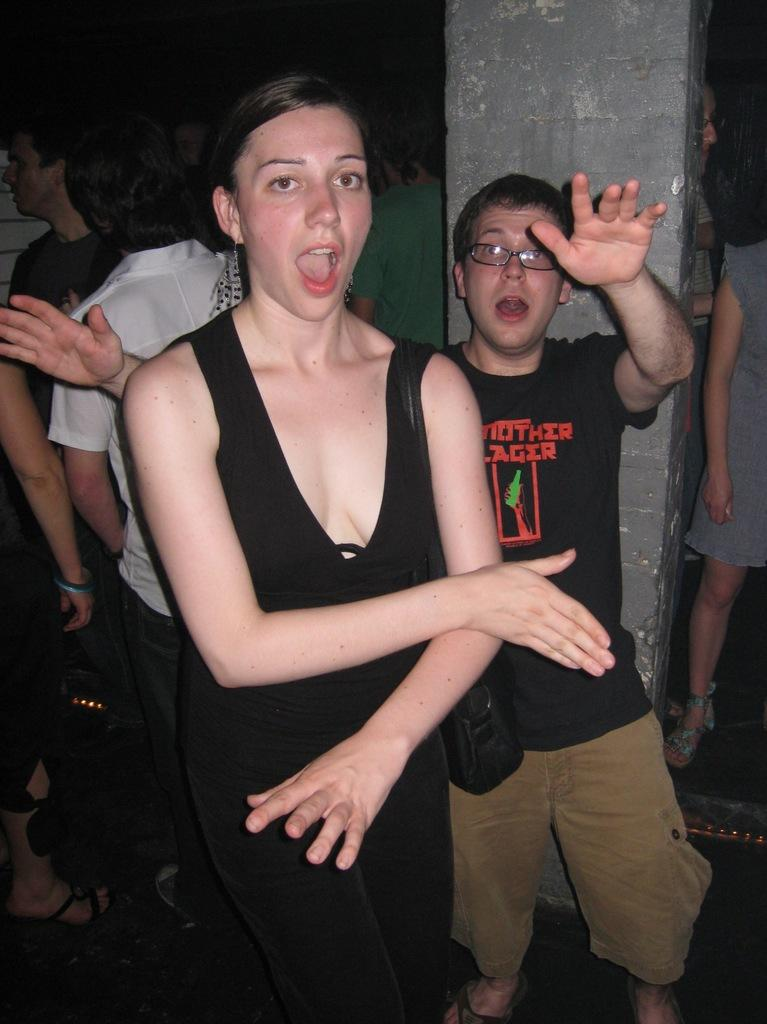How many people are in the image? There are persons in the image. What is the woman in the front of the image doing? The woman is dancing in the front of the image. What color is the dress the woman is wearing? The woman is wearing a black dress. What can be seen in the background of the image? There is a pillar in the background of the image. What is at the bottom of the image? There is a floor at the bottom of the image. What type of rub is the woman applying to her hands in the image? There is no rub visible in the image; the woman is dancing while wearing a black dress. 